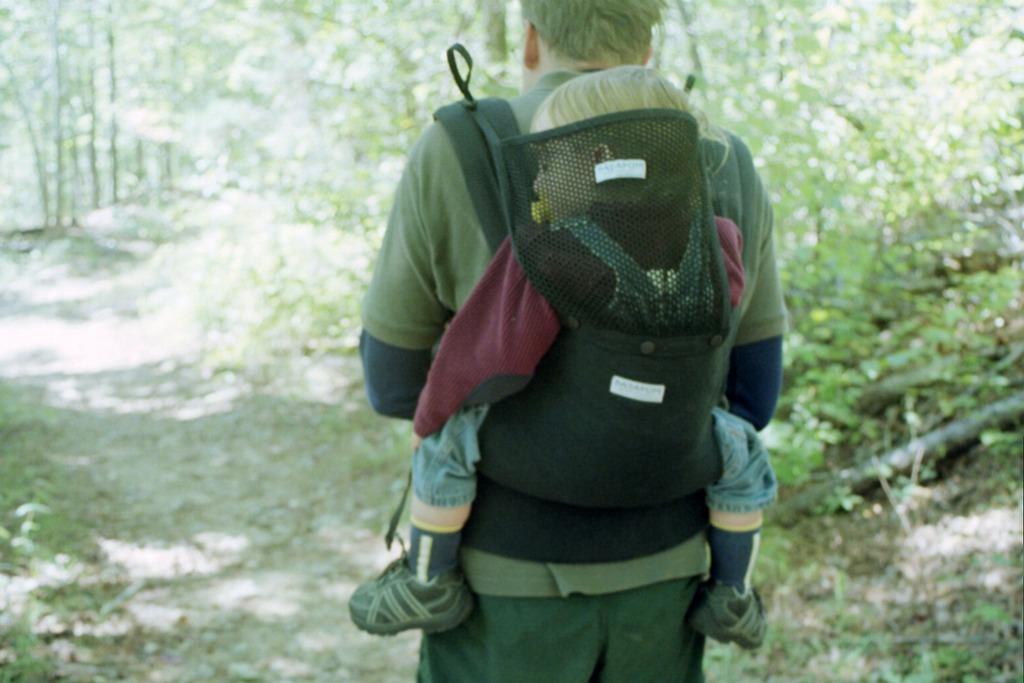How would you summarize this image in a sentence or two? In this image we can see a person and a kid. In the background of the image there are trees, plants, ground and other objects. 